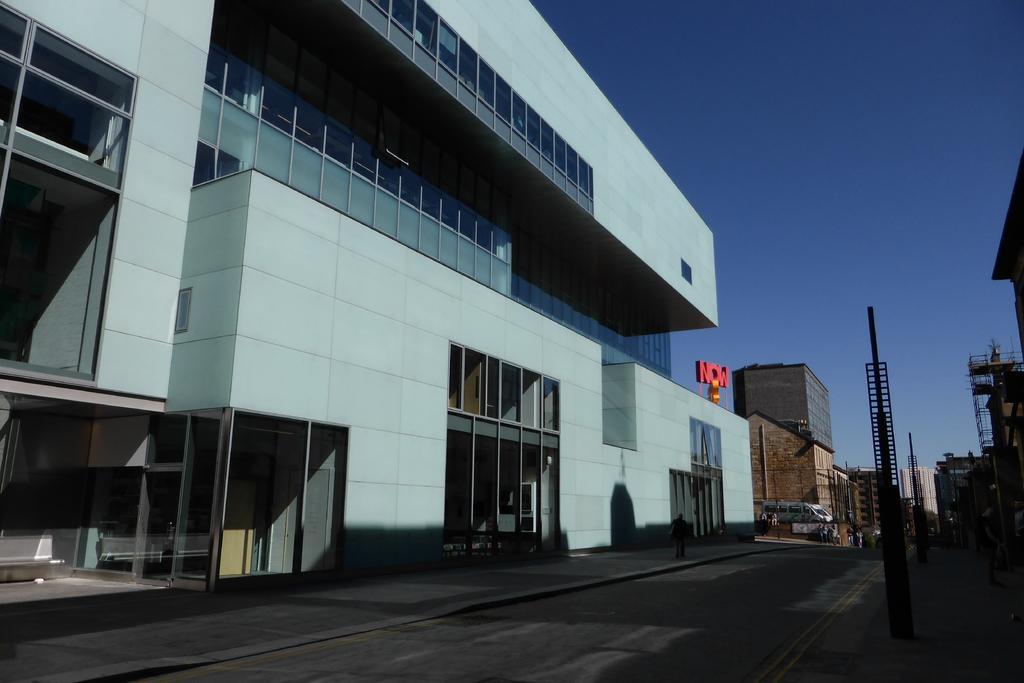Please provide a concise description of this image. In this image I can see at the bottom it is the road. On the left side there are buildings with window glasses, in the middle there is the name in red color light. At the top it is the sky. 